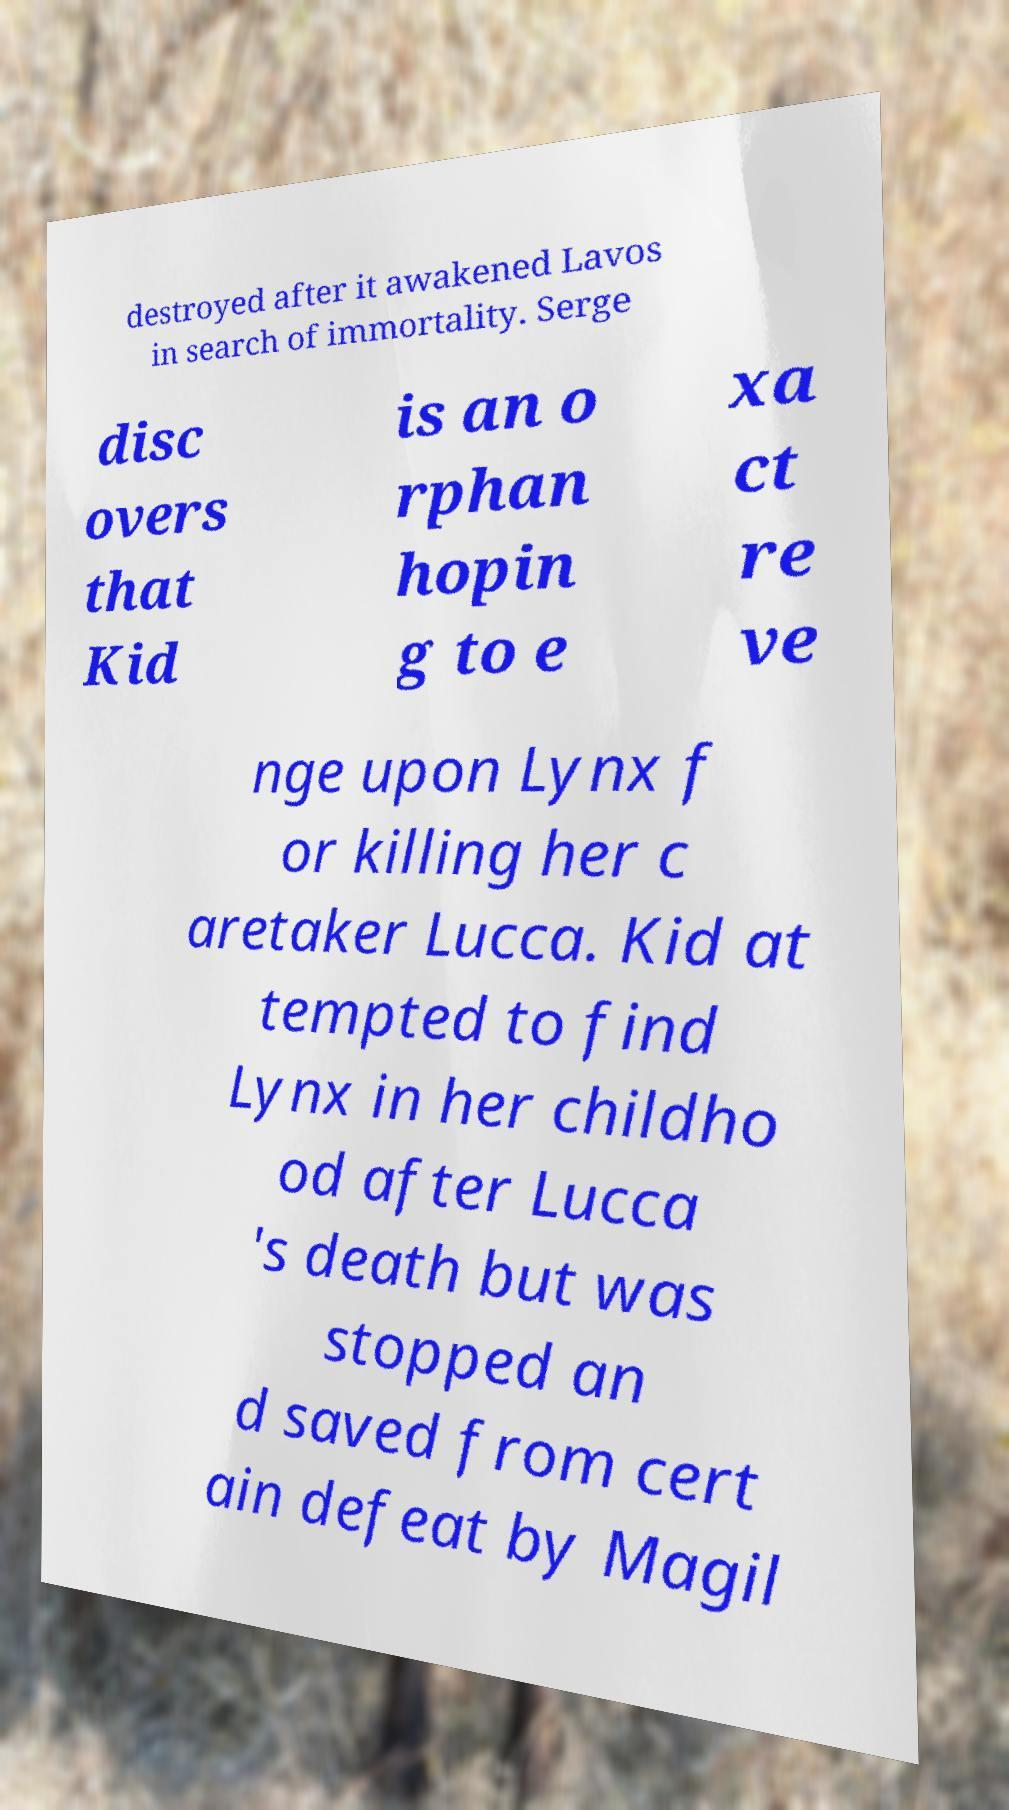Can you accurately transcribe the text from the provided image for me? destroyed after it awakened Lavos in search of immortality. Serge disc overs that Kid is an o rphan hopin g to e xa ct re ve nge upon Lynx f or killing her c aretaker Lucca. Kid at tempted to find Lynx in her childho od after Lucca 's death but was stopped an d saved from cert ain defeat by Magil 